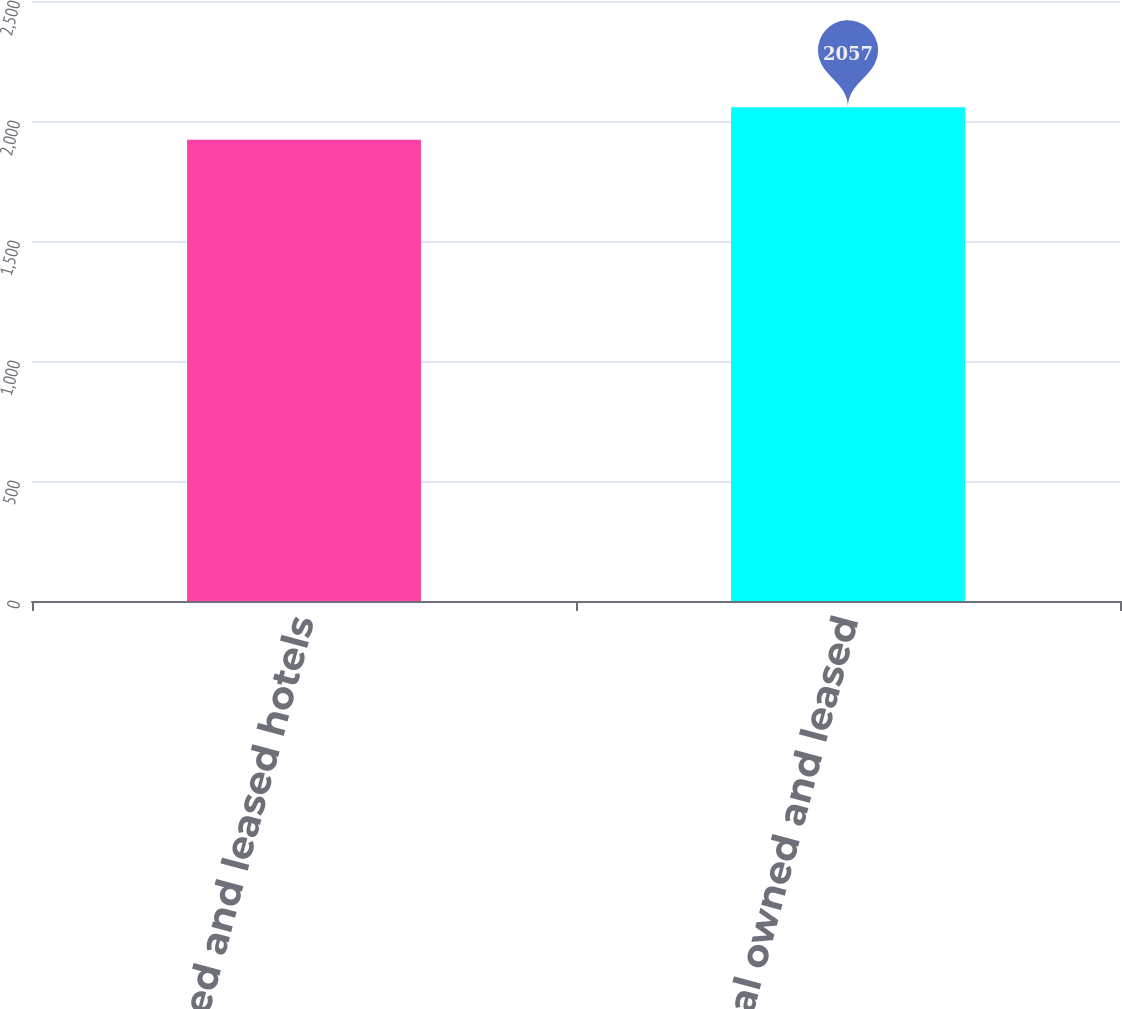Convert chart to OTSL. <chart><loc_0><loc_0><loc_500><loc_500><bar_chart><fcel>US owned and leased hotels<fcel>International owned and leased<nl><fcel>1922<fcel>2057<nl></chart> 